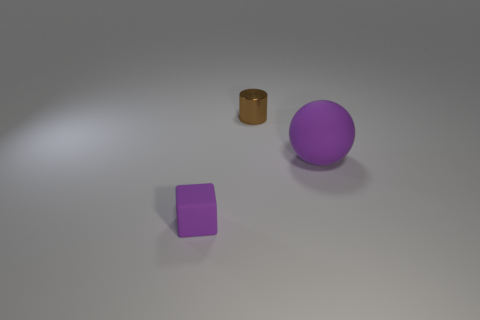What is the size of the block that is the same color as the big object?
Ensure brevity in your answer.  Small. There is a small rubber thing; is its shape the same as the thing that is on the right side of the small brown metal object?
Your answer should be compact. No. What number of things are small objects behind the tiny purple rubber thing or things to the left of the small metal thing?
Provide a succinct answer. 2. There is a small object that is the same color as the big matte thing; what shape is it?
Offer a terse response. Cube. What is the shape of the matte object that is on the right side of the tiny rubber block?
Give a very brief answer. Sphere. What number of things are small purple rubber cubes that are to the left of the big purple rubber thing or purple matte spheres?
Ensure brevity in your answer.  2. Is there anything else that is the same color as the metallic thing?
Offer a terse response. No. There is a purple rubber thing that is in front of the big purple ball; what is its size?
Your answer should be compact. Small. There is a small metallic cylinder; does it have the same color as the ball right of the tiny purple cube?
Give a very brief answer. No. What number of other objects are the same material as the tiny cylinder?
Offer a terse response. 0. 